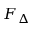Convert formula to latex. <formula><loc_0><loc_0><loc_500><loc_500>F _ { \Delta }</formula> 